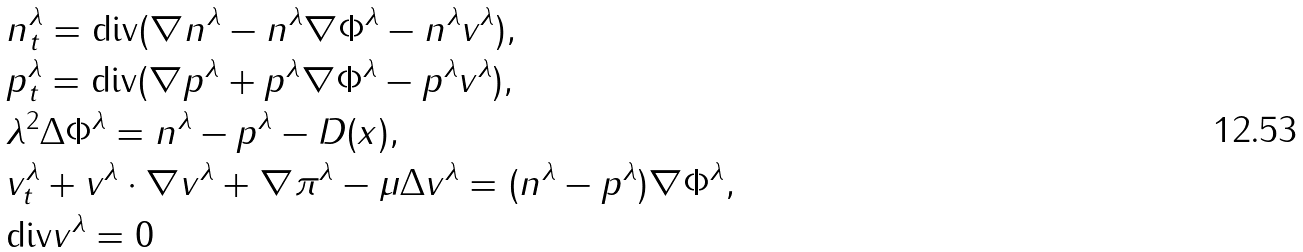Convert formula to latex. <formula><loc_0><loc_0><loc_500><loc_500>& n ^ { \lambda } _ { t } = \text {div} ( \nabla n ^ { \lambda } - n ^ { \lambda } \nabla \Phi ^ { \lambda } - n ^ { \lambda } v ^ { \lambda } ) , \\ & p ^ { \lambda } _ { t } = \text {div} ( \nabla p ^ { \lambda } + p ^ { \lambda } \nabla \Phi ^ { \lambda } - p ^ { \lambda } v ^ { \lambda } ) , \\ & \lambda ^ { 2 } \Delta \Phi ^ { \lambda } = n ^ { \lambda } - p ^ { \lambda } - D ( x ) , \\ & v ^ { \lambda } _ { t } + v ^ { \lambda } \cdot \nabla v ^ { \lambda } + \nabla \pi ^ { \lambda } - \mu \Delta v ^ { \lambda } = ( n ^ { \lambda } - p ^ { \lambda } ) \nabla \Phi ^ { \lambda } , \\ & \text {div} v ^ { \lambda } = 0</formula> 